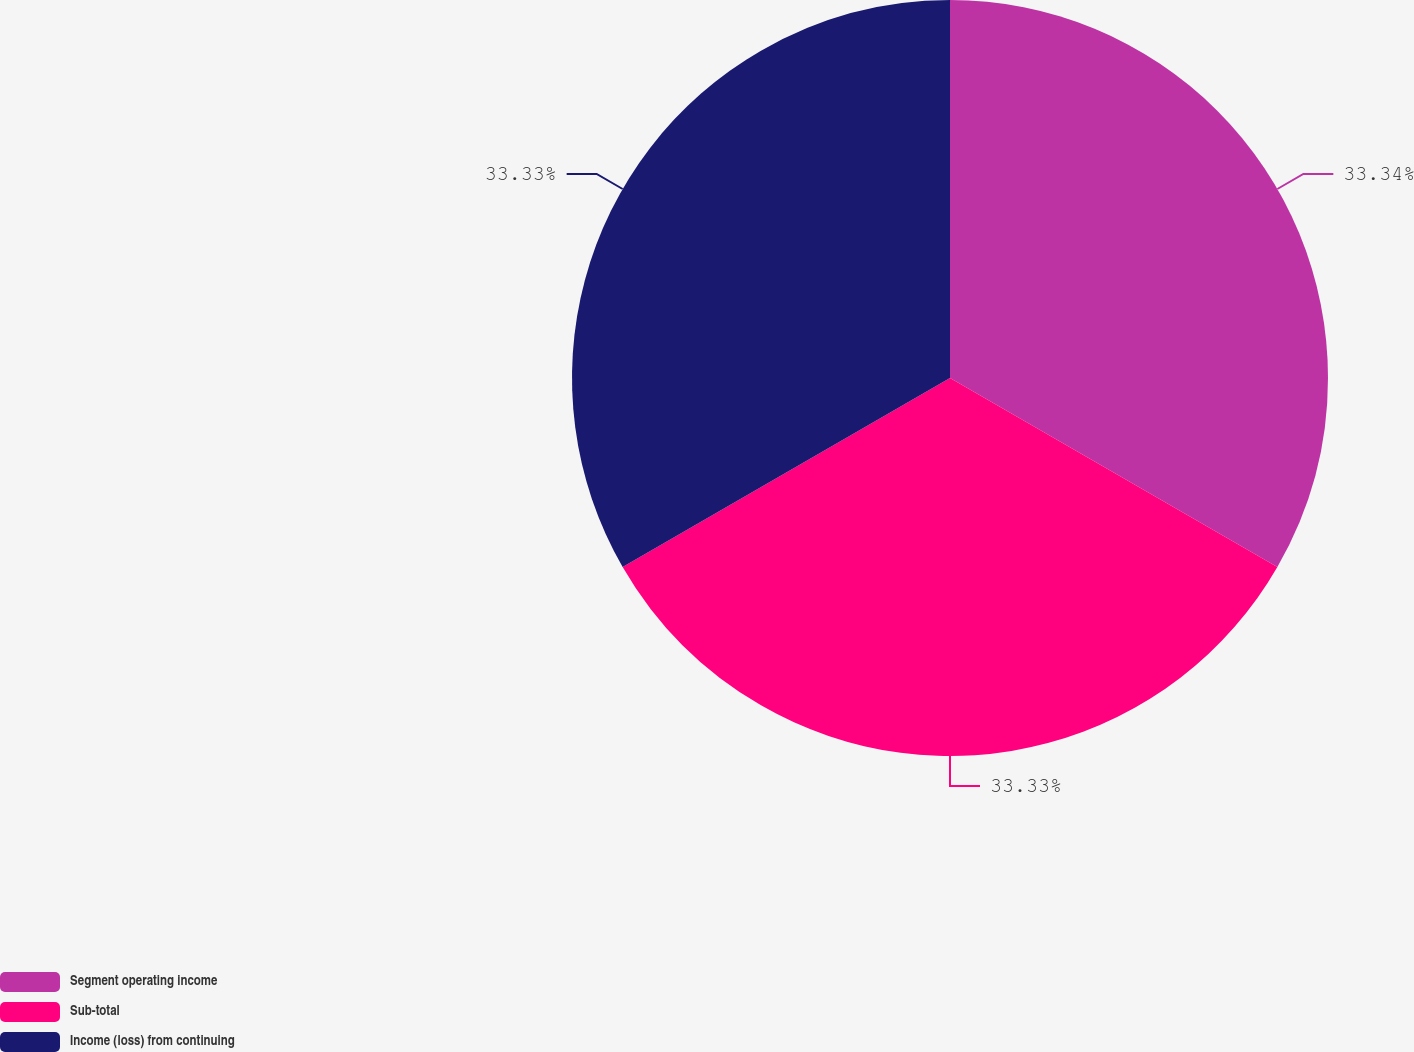Convert chart. <chart><loc_0><loc_0><loc_500><loc_500><pie_chart><fcel>Segment operating income<fcel>Sub-total<fcel>Income (loss) from continuing<nl><fcel>33.33%<fcel>33.33%<fcel>33.33%<nl></chart> 